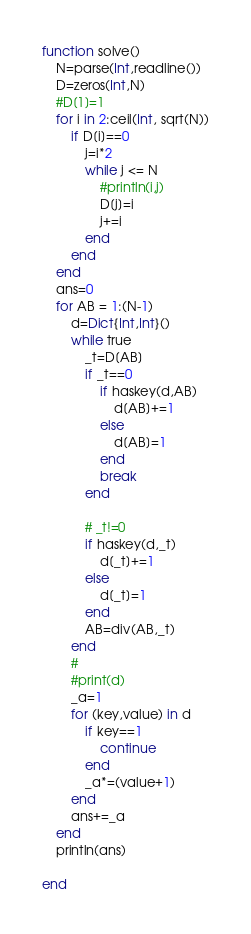Convert code to text. <code><loc_0><loc_0><loc_500><loc_500><_Julia_>function solve()
    N=parse(Int,readline())
    D=zeros(Int,N)
    #D[1]=1
    for i in 2:ceil(Int, sqrt(N))
        if D[i]==0
            j=i*2
            while j <= N
                #println(i,j)
                D[j]=i
                j+=i
            end
        end
    end
    ans=0
    for AB = 1:(N-1)
        d=Dict{Int,Int}()
        while true
            _t=D[AB]
            if _t==0
                if haskey(d,AB)
                    d[AB]+=1
                else
                    d[AB]=1
                end
                break
            end

            # _t!=0
            if haskey(d,_t)
                d[_t]+=1
            else
                d[_t]=1
            end
            AB=div(AB,_t)
        end
        #
        #print(d)
        _a=1
        for (key,value) in d
            if key==1
                continue
            end
            _a*=(value+1)
        end
        ans+=_a
    end
    println(ans)

end</code> 